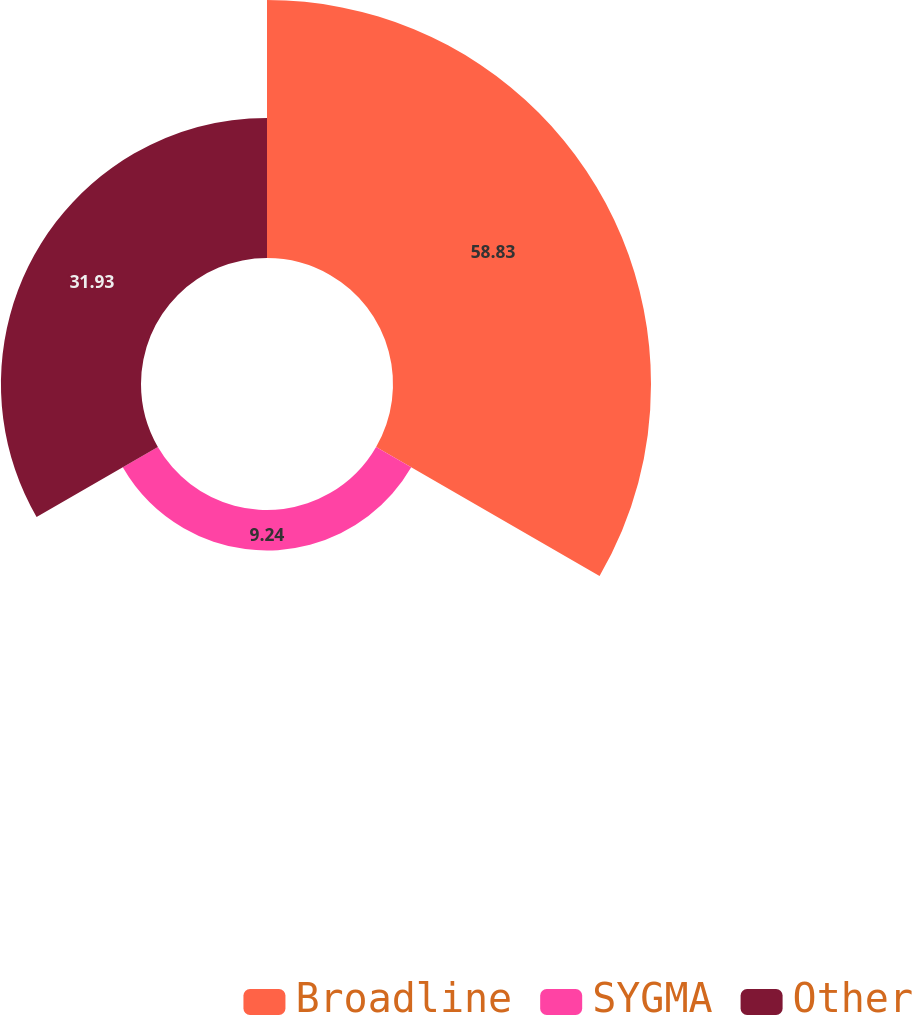<chart> <loc_0><loc_0><loc_500><loc_500><pie_chart><fcel>Broadline<fcel>SYGMA<fcel>Other<nl><fcel>58.82%<fcel>9.24%<fcel>31.93%<nl></chart> 